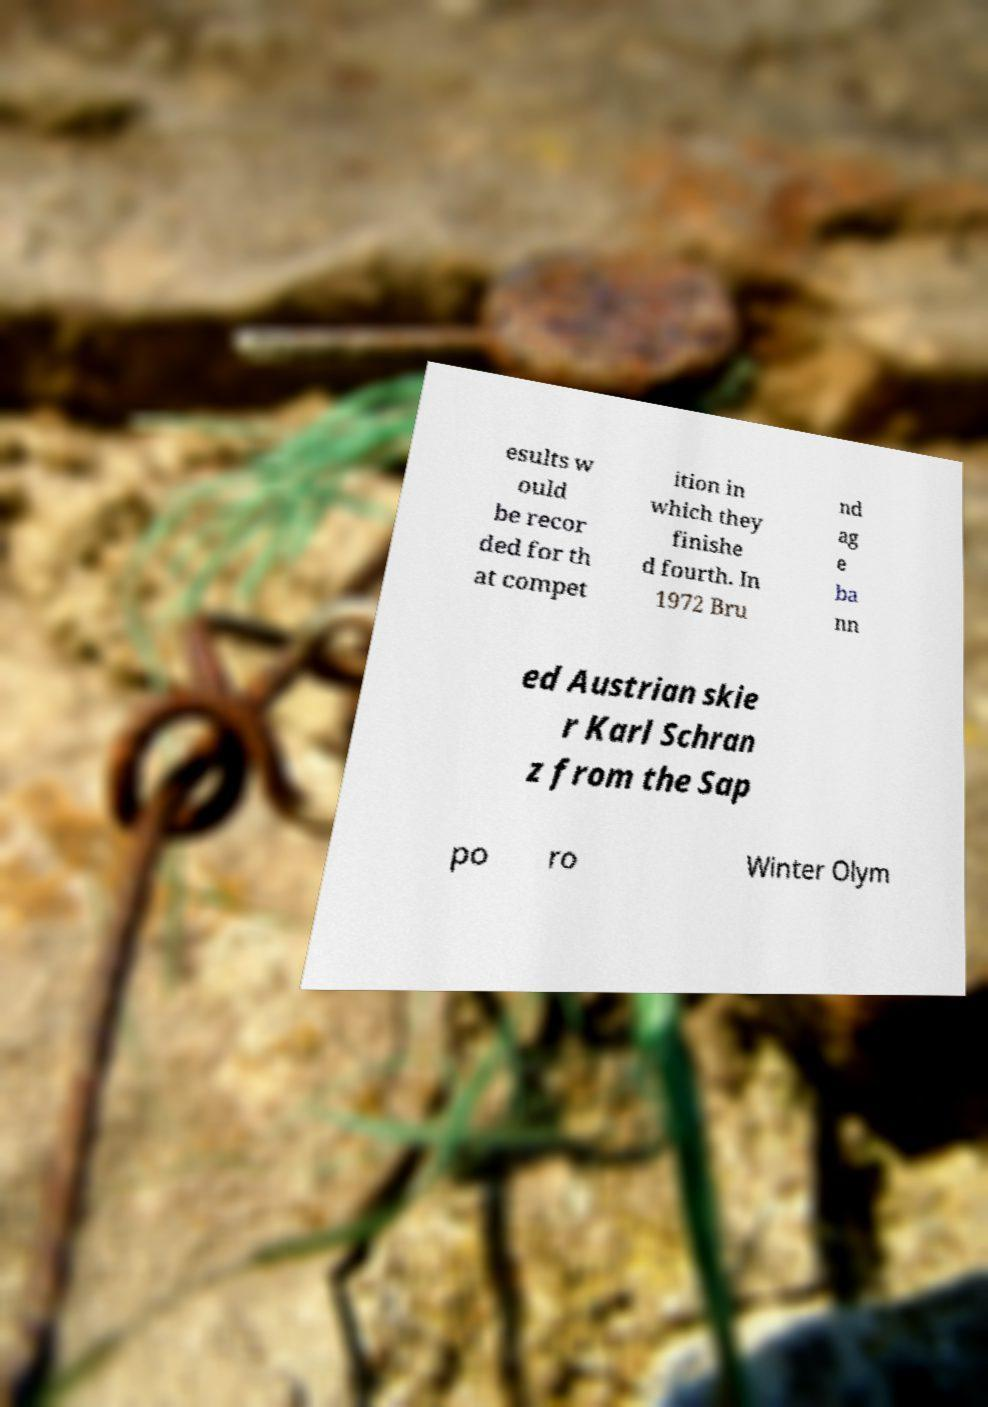Can you accurately transcribe the text from the provided image for me? esults w ould be recor ded for th at compet ition in which they finishe d fourth. In 1972 Bru nd ag e ba nn ed Austrian skie r Karl Schran z from the Sap po ro Winter Olym 